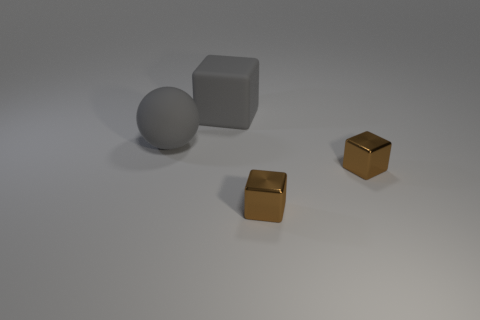Is there any other thing that has the same color as the ball?
Offer a terse response. Yes. Does the ball have the same material as the large thing behind the large rubber sphere?
Offer a very short reply. Yes. What number of things are either gray balls that are in front of the gray rubber cube or big shiny objects?
Keep it short and to the point. 1. Is there a big sphere of the same color as the matte block?
Offer a very short reply. Yes. What number of things are on the right side of the large gray sphere and in front of the big rubber block?
Ensure brevity in your answer.  2. How big is the gray matte thing behind the big gray thing that is in front of the matte cube?
Give a very brief answer. Large. Are any big gray rubber balls visible?
Provide a succinct answer. Yes. Are there more tiny brown cubes that are left of the large matte cube than things that are on the right side of the matte ball?
Provide a short and direct response. No. Is there a shiny block of the same size as the matte cube?
Provide a succinct answer. No. There is a gray matte thing that is to the left of the gray rubber thing that is on the right side of the gray ball that is to the left of the big matte cube; what size is it?
Offer a terse response. Large. 